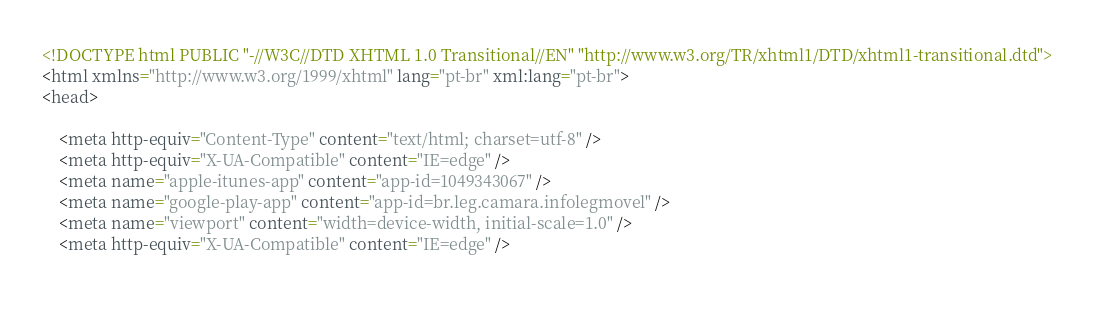<code> <loc_0><loc_0><loc_500><loc_500><_HTML_>




<!DOCTYPE html PUBLIC "-//W3C//DTD XHTML 1.0 Transitional//EN" "http://www.w3.org/TR/xhtml1/DTD/xhtml1-transitional.dtd">
<html xmlns="http://www.w3.org/1999/xhtml" lang="pt-br" xml:lang="pt-br">
<head>
	    
    <meta http-equiv="Content-Type" content="text/html; charset=utf-8" />
    <meta http-equiv="X-UA-Compatible" content="IE=edge" />
    <meta name="apple-itunes-app" content="app-id=1049343067" />
    <meta name="google-play-app" content="app-id=br.leg.camara.infolegmovel" />
    <meta name="viewport" content="width=device-width, initial-scale=1.0" />
	<meta http-equiv="X-UA-Compatible" content="IE=edge" /> 
    </code> 